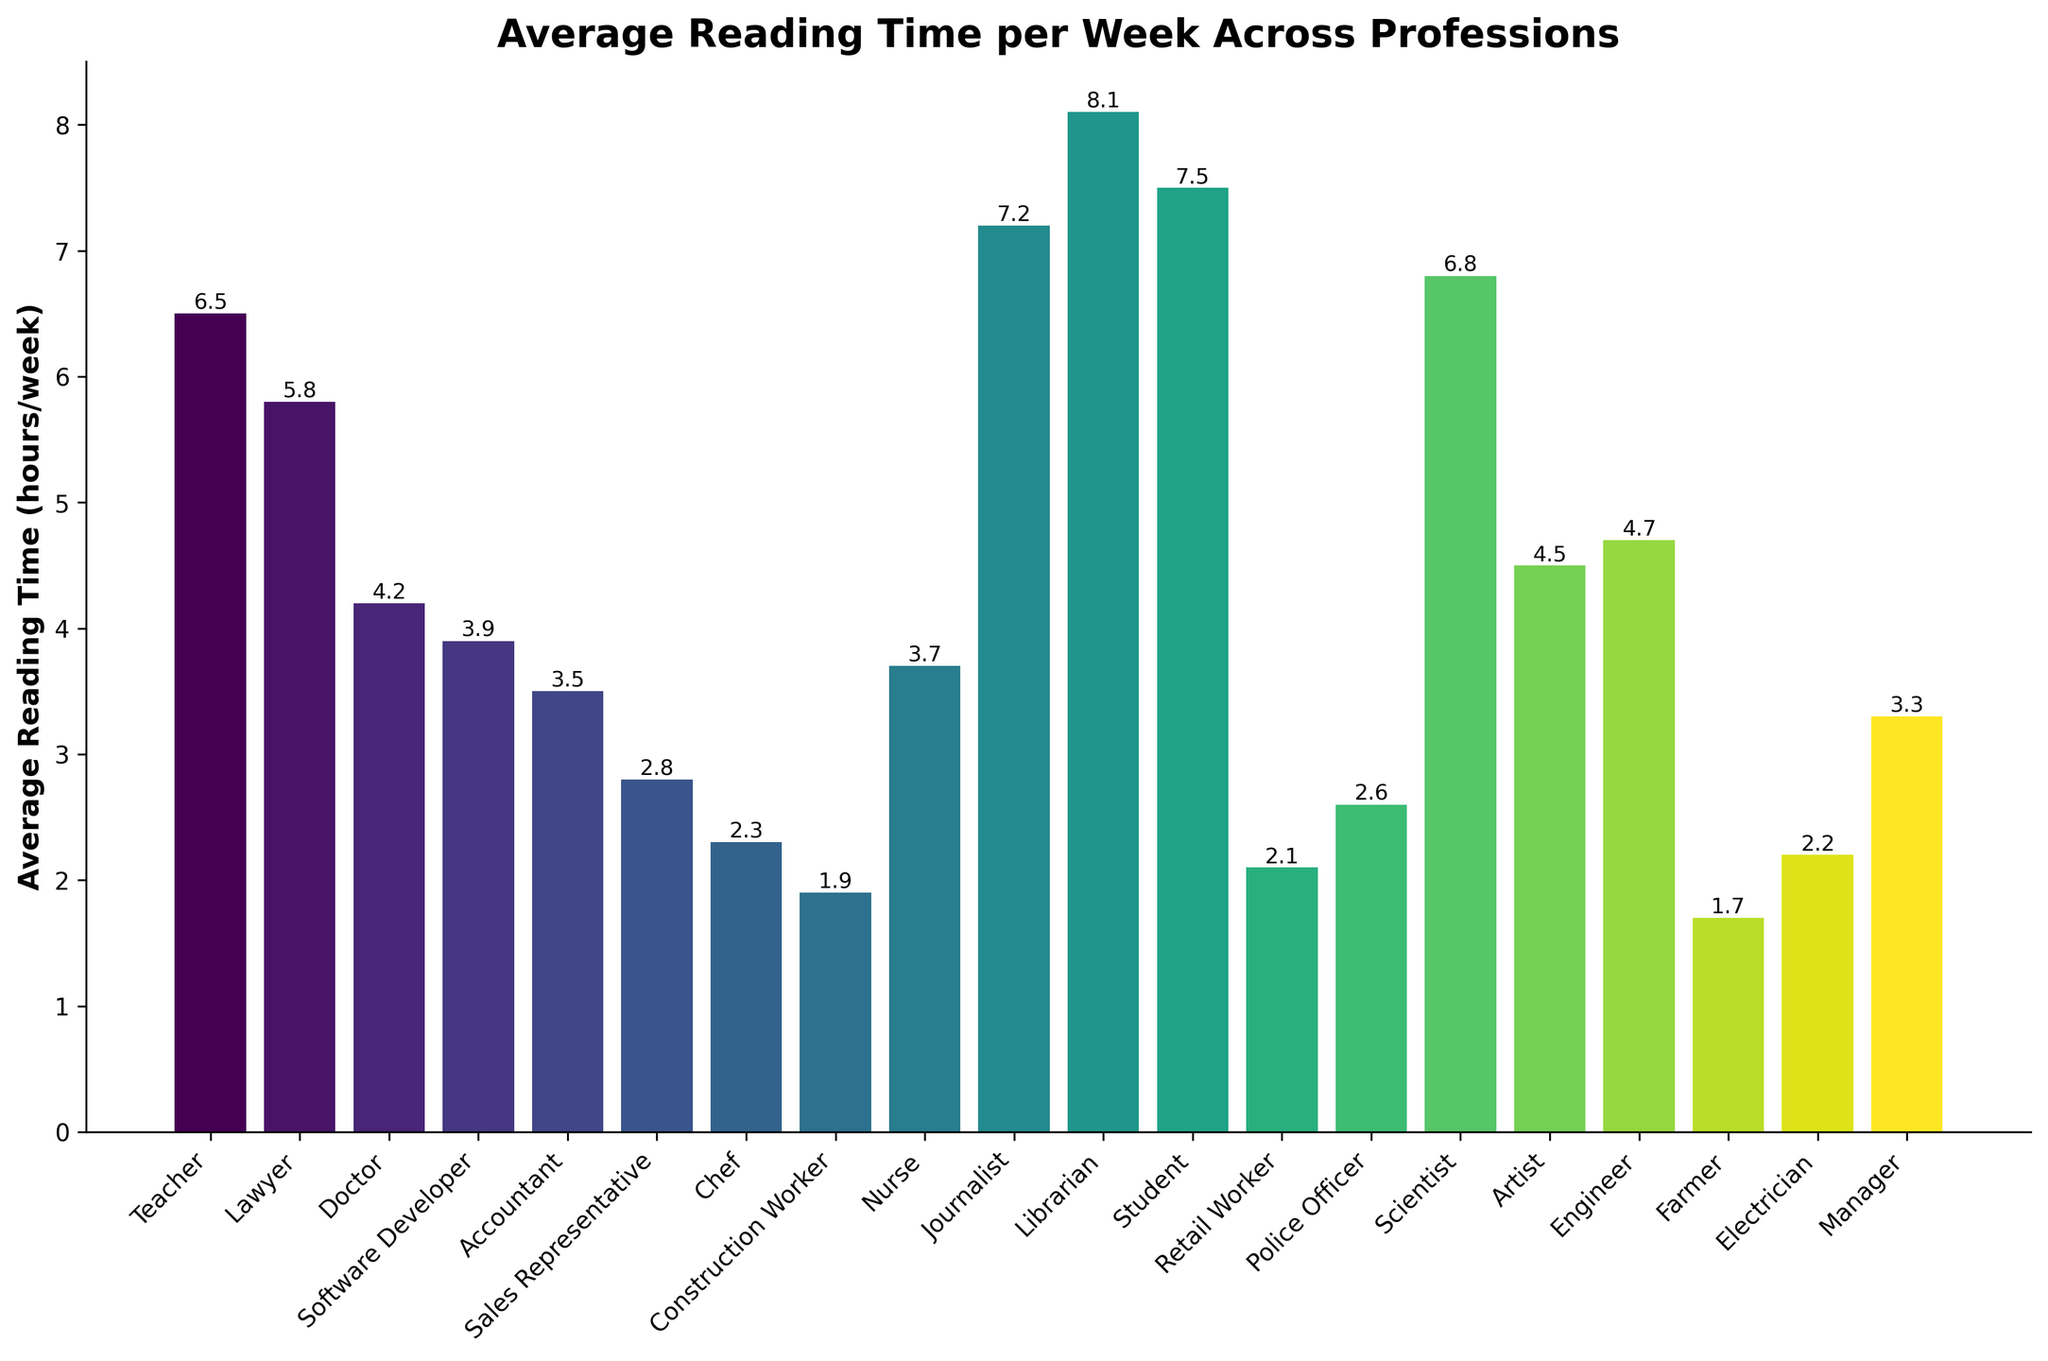Which profession spends the most time reading per week on average? By examining the height of the bars, we see that "Librarian" has the tallest bar at 8.1 hours per week.
Answer: Librarian Which profession spends the least time reading per week on average? By identifying the shortest bar, we find that "Farmer" spends the least time reading at 1.7 hours per week.
Answer: Farmer How many hours more do Librarians spend reading compared to Engineers? Librarians spend 8.1 hours while Engineers spend 4.7 hours. Subtracting these gives 8.1 - 4.7 = 3.4 hours.
Answer: 3.4 hours Which professions spend more than 6 hours per week reading on average? By locating the bars that exceed the 6-hour mark, we find that Librarians, Students, Journalists, Scientists, and Teachers all spend more than 6 hours per week reading.
Answer: Librarian, Student, Journalist, Scientist, Teacher What is the average reading time per week for Doctors and Nurses combined? Adding the weekly reading times for Doctors (4.2) and Nurses (3.7) gives 4.2 + 3.7 = 7.9 hours. Dividing by 2 for the average results in 7.9 / 2 = 3.95 hours per week.
Answer: 3.95 hours Which profession spends the second most time reading per week on average? The second tallest bar after Librarians (8.1) is for Students at 7.5 hours per week.
Answer: Student How much more time do Lawyers spend reading compared to Sales Representatives per week? Lawyers spend 5.8 hours and Sales Representatives spend 2.8 hours. The difference is 5.8 - 2.8 = 3.
Answer: 3 hours Which profession spends around 3 hours reading per week on average? Examining the bars close to the 3-hour mark, we find Manager at 3.3 hours, Software Developer at 3.9 hours, and Nurse at 3.7 hours. The closest one is Manager at 3.3 hours.
Answer: Manager Is the reading time of Accountants greater than that of Artists? The bar for Accountants shows 3.5 hours, while the bar for Artists shows 4.5 hours. Hence, Accountants spend less time reading than Artists.
Answer: No What is the combined average reading time per week for all professions below 3 hours? Adding reading times for Sales Representative (2.8), Chef (2.3), Construction Worker (1.9), Retail Worker (2.1), Police Officer (2.6), Farmer (1.7), and Electrician (2.2) gives the total of 2.8 + 2.3 + 1.9 + 2.1 + 2.6 + 1.7 + 2.2 = 15.6. Dividing by 7 gives 15.6 / 7 = 2.23 hours.
Answer: 2.23 hours 